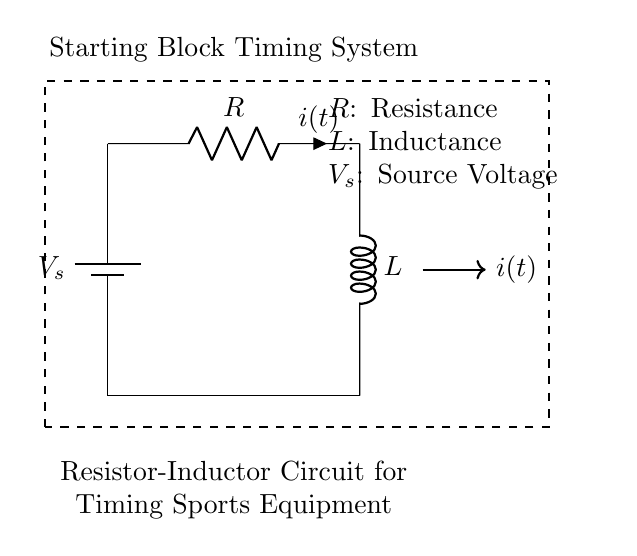What components are present in this circuit? The circuit contains a battery, a resistor, and an inductor. These are essential components that determine the behavior of the circuit.
Answer: battery, resistor, inductor What is the purpose of the resistor in this circuit? The resistor limits current flow and dissipates energy in the form of heat, which is crucial for controlling the timing characteristics in the circuit.
Answer: limit current What is the symbol for the voltage source in the diagram? The voltage source is depicted with a battery symbol that clearly shows the positive and negative terminals of the voltage supply.
Answer: battery What does the symbol 'i(t)' represent? The symbol 'i(t)' represents the instantaneous current flowing through the circuit at any given time, indicating the time-dependent nature of current in an RL circuit.
Answer: instantaneous current How does the inductor affect the circuit's timing behavior? The inductor introduces a phase shift and delays the current change in response to voltage, impacting the timing response in the starting block system significantly.
Answer: delays current What is the relationship between resistance and the response time of the circuit? Resistance affects the rate at which current builds up through the inductor; higher resistance leads to a longer time constant, thus increasing the response time of the circuit.
Answer: longer response time What does 'L' denote in this circuit? 'L' denotes the inductance, which quantifies the ability of the inductor to store energy in a magnetic field as current flows through it, essential for timing applications.
Answer: inductance 